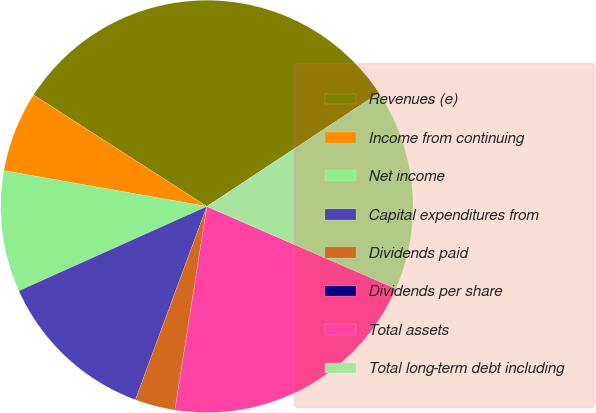Convert chart to OTSL. <chart><loc_0><loc_0><loc_500><loc_500><pie_chart><fcel>Revenues (e)<fcel>Income from continuing<fcel>Net income<fcel>Capital expenditures from<fcel>Dividends paid<fcel>Dividends per share<fcel>Total assets<fcel>Total long-term debt including<nl><fcel>31.62%<fcel>6.32%<fcel>9.49%<fcel>12.65%<fcel>3.16%<fcel>0.0%<fcel>20.94%<fcel>15.81%<nl></chart> 